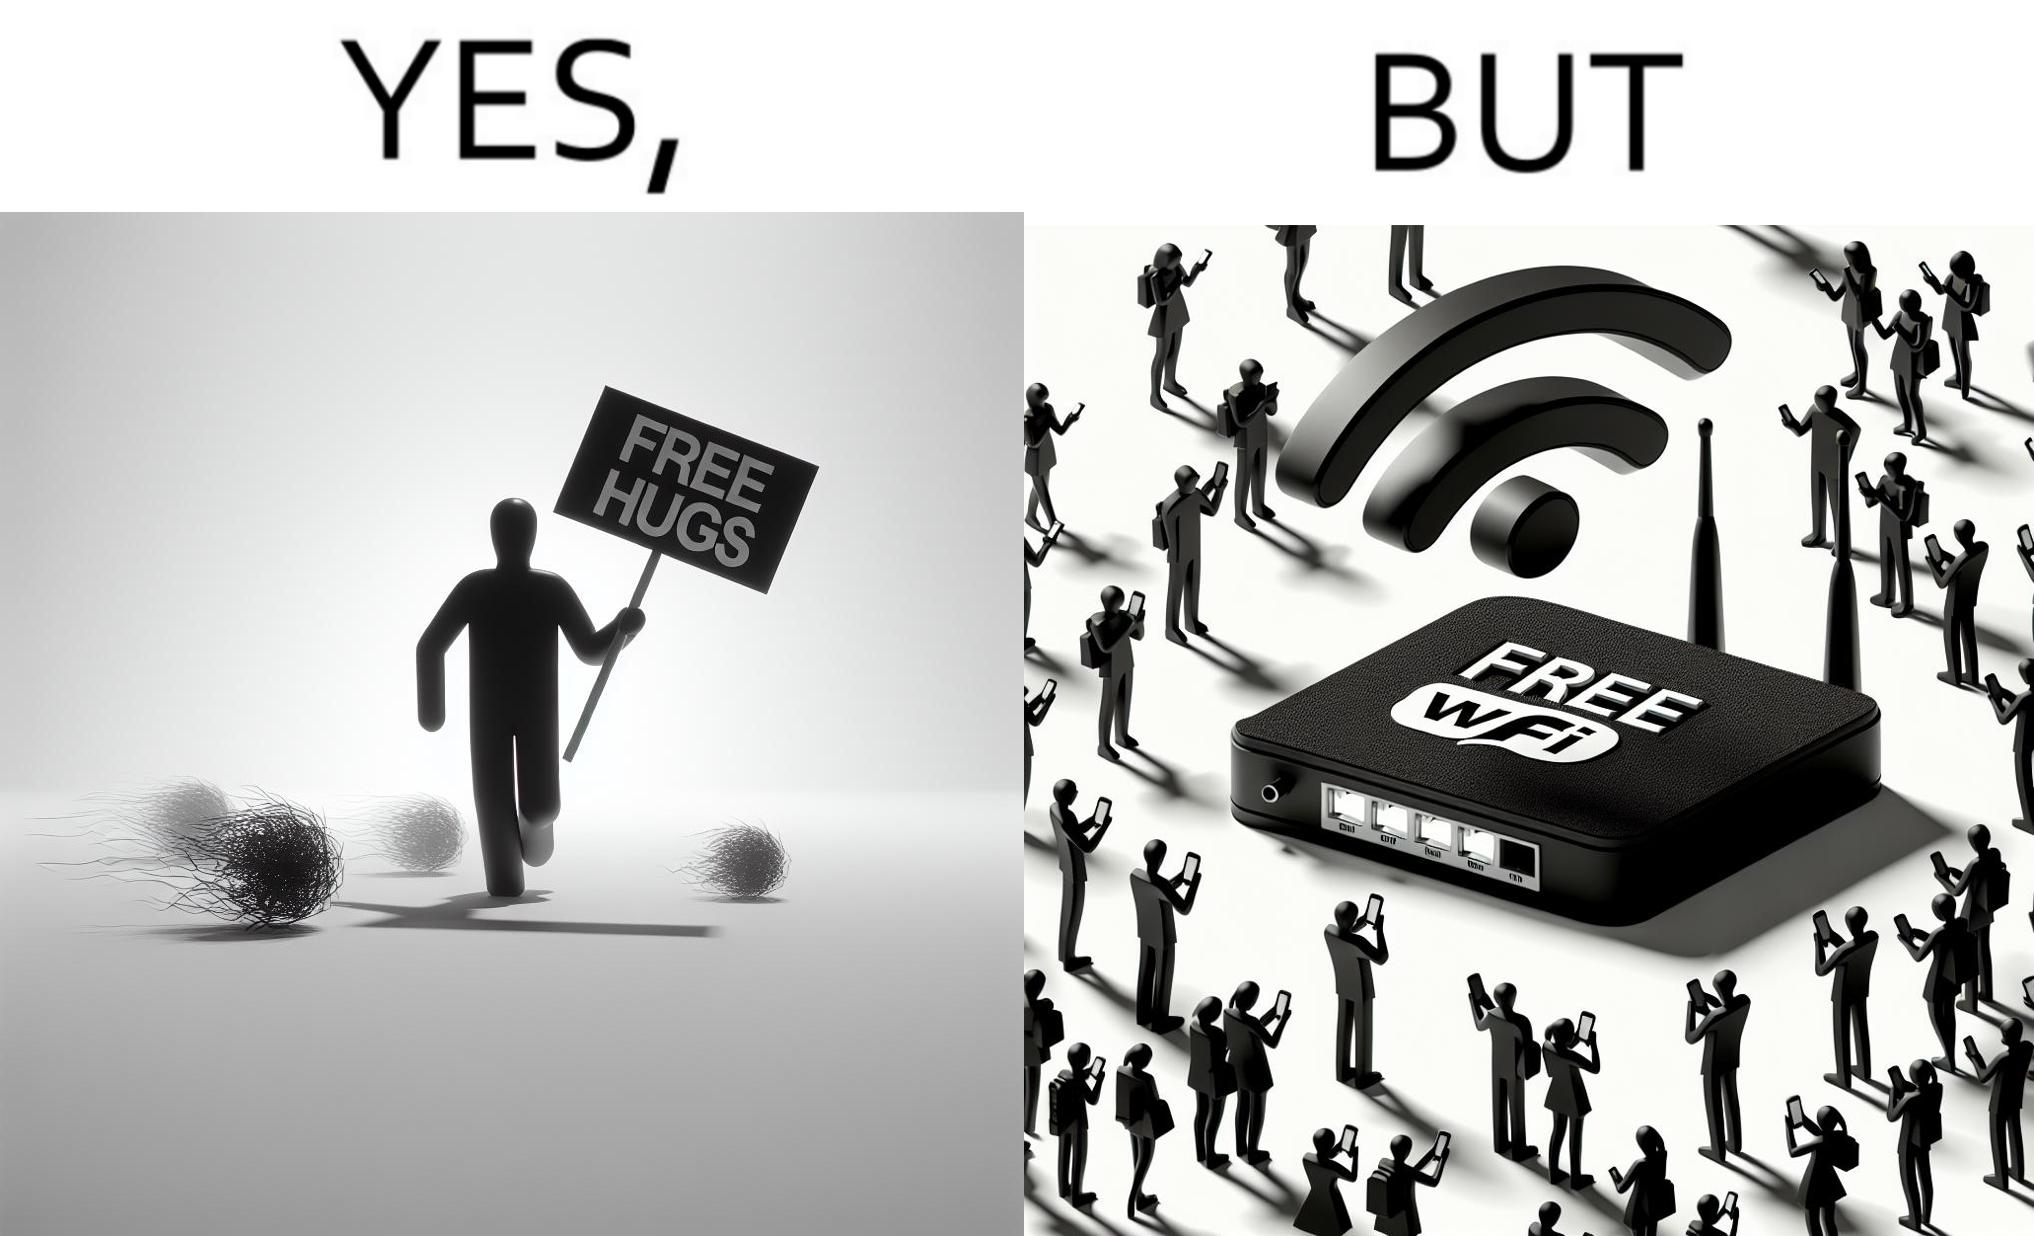Does this image contain satire or humor? Yes, this image is satirical. 